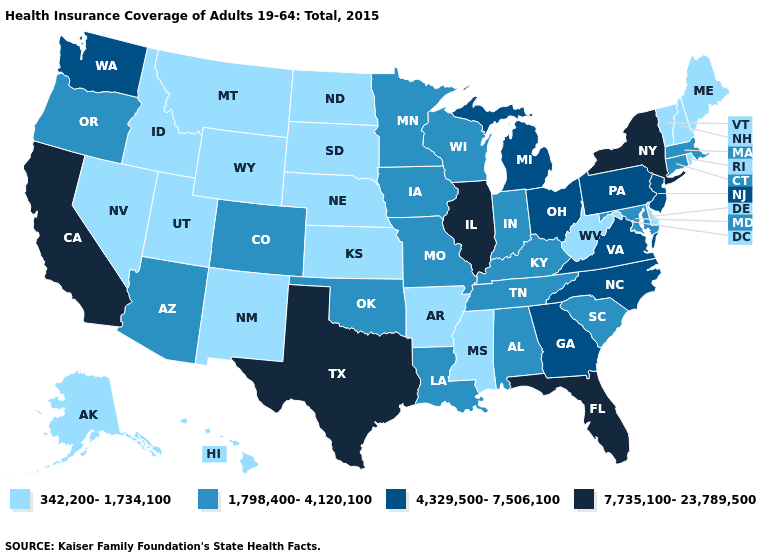What is the value of Florida?
Be succinct. 7,735,100-23,789,500. Name the states that have a value in the range 7,735,100-23,789,500?
Write a very short answer. California, Florida, Illinois, New York, Texas. Does Nebraska have the lowest value in the MidWest?
Keep it brief. Yes. Name the states that have a value in the range 1,798,400-4,120,100?
Concise answer only. Alabama, Arizona, Colorado, Connecticut, Indiana, Iowa, Kentucky, Louisiana, Maryland, Massachusetts, Minnesota, Missouri, Oklahoma, Oregon, South Carolina, Tennessee, Wisconsin. What is the value of Arizona?
Write a very short answer. 1,798,400-4,120,100. Does Kentucky have the lowest value in the USA?
Answer briefly. No. What is the value of Kansas?
Keep it brief. 342,200-1,734,100. Does Iowa have the same value as Louisiana?
Quick response, please. Yes. Among the states that border Tennessee , does Missouri have the lowest value?
Concise answer only. No. Which states have the highest value in the USA?
Concise answer only. California, Florida, Illinois, New York, Texas. Name the states that have a value in the range 1,798,400-4,120,100?
Short answer required. Alabama, Arizona, Colorado, Connecticut, Indiana, Iowa, Kentucky, Louisiana, Maryland, Massachusetts, Minnesota, Missouri, Oklahoma, Oregon, South Carolina, Tennessee, Wisconsin. Name the states that have a value in the range 342,200-1,734,100?
Concise answer only. Alaska, Arkansas, Delaware, Hawaii, Idaho, Kansas, Maine, Mississippi, Montana, Nebraska, Nevada, New Hampshire, New Mexico, North Dakota, Rhode Island, South Dakota, Utah, Vermont, West Virginia, Wyoming. What is the value of Florida?
Quick response, please. 7,735,100-23,789,500. What is the value of South Carolina?
Short answer required. 1,798,400-4,120,100. Name the states that have a value in the range 1,798,400-4,120,100?
Answer briefly. Alabama, Arizona, Colorado, Connecticut, Indiana, Iowa, Kentucky, Louisiana, Maryland, Massachusetts, Minnesota, Missouri, Oklahoma, Oregon, South Carolina, Tennessee, Wisconsin. 